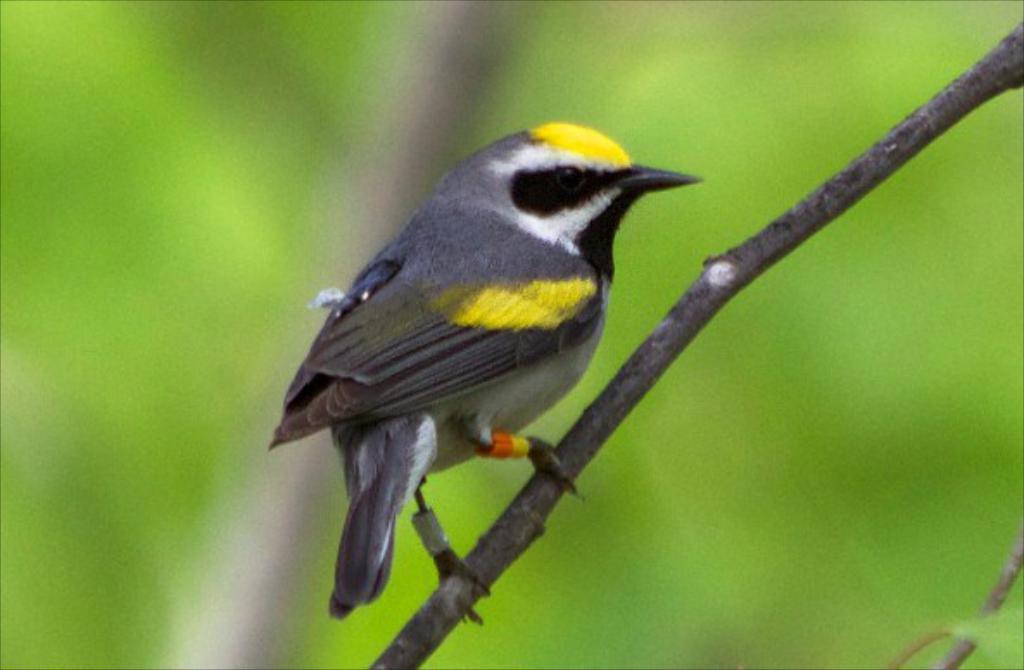Describe this image in one or two sentences. As we can see in the image there is a bird. The bird is in yellow and grey color. The background is blurred. 